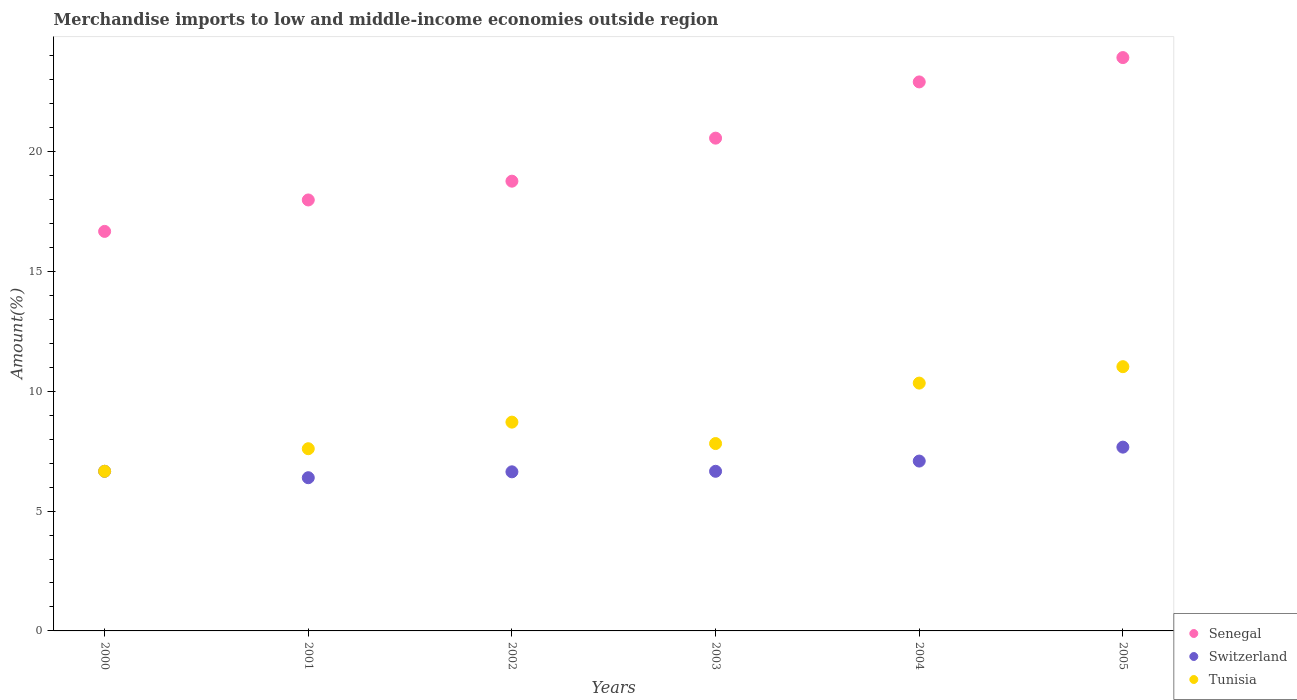Is the number of dotlines equal to the number of legend labels?
Keep it short and to the point. Yes. What is the percentage of amount earned from merchandise imports in Senegal in 2005?
Offer a terse response. 23.92. Across all years, what is the maximum percentage of amount earned from merchandise imports in Tunisia?
Offer a very short reply. 11.03. Across all years, what is the minimum percentage of amount earned from merchandise imports in Switzerland?
Offer a terse response. 6.39. What is the total percentage of amount earned from merchandise imports in Senegal in the graph?
Offer a terse response. 120.8. What is the difference between the percentage of amount earned from merchandise imports in Senegal in 2002 and that in 2005?
Your response must be concise. -5.16. What is the difference between the percentage of amount earned from merchandise imports in Senegal in 2001 and the percentage of amount earned from merchandise imports in Tunisia in 2005?
Provide a succinct answer. 6.96. What is the average percentage of amount earned from merchandise imports in Tunisia per year?
Make the answer very short. 8.69. In the year 2005, what is the difference between the percentage of amount earned from merchandise imports in Senegal and percentage of amount earned from merchandise imports in Switzerland?
Provide a short and direct response. 16.25. What is the ratio of the percentage of amount earned from merchandise imports in Senegal in 2003 to that in 2004?
Give a very brief answer. 0.9. Is the difference between the percentage of amount earned from merchandise imports in Senegal in 2001 and 2002 greater than the difference between the percentage of amount earned from merchandise imports in Switzerland in 2001 and 2002?
Give a very brief answer. No. What is the difference between the highest and the second highest percentage of amount earned from merchandise imports in Tunisia?
Offer a terse response. 0.69. What is the difference between the highest and the lowest percentage of amount earned from merchandise imports in Senegal?
Ensure brevity in your answer.  7.25. Is the percentage of amount earned from merchandise imports in Tunisia strictly greater than the percentage of amount earned from merchandise imports in Switzerland over the years?
Provide a succinct answer. Yes. How many dotlines are there?
Provide a short and direct response. 3. Does the graph contain grids?
Your response must be concise. No. Where does the legend appear in the graph?
Your response must be concise. Bottom right. How many legend labels are there?
Offer a very short reply. 3. What is the title of the graph?
Ensure brevity in your answer.  Merchandise imports to low and middle-income economies outside region. What is the label or title of the Y-axis?
Ensure brevity in your answer.  Amount(%). What is the Amount(%) in Senegal in 2000?
Provide a short and direct response. 16.67. What is the Amount(%) of Switzerland in 2000?
Make the answer very short. 6.66. What is the Amount(%) of Tunisia in 2000?
Your answer should be compact. 6.66. What is the Amount(%) in Senegal in 2001?
Provide a short and direct response. 17.98. What is the Amount(%) of Switzerland in 2001?
Your answer should be very brief. 6.39. What is the Amount(%) in Tunisia in 2001?
Make the answer very short. 7.6. What is the Amount(%) in Senegal in 2002?
Your response must be concise. 18.76. What is the Amount(%) in Switzerland in 2002?
Keep it short and to the point. 6.64. What is the Amount(%) in Tunisia in 2002?
Your response must be concise. 8.71. What is the Amount(%) in Senegal in 2003?
Provide a short and direct response. 20.56. What is the Amount(%) of Switzerland in 2003?
Make the answer very short. 6.66. What is the Amount(%) of Tunisia in 2003?
Make the answer very short. 7.82. What is the Amount(%) of Senegal in 2004?
Offer a very short reply. 22.91. What is the Amount(%) in Switzerland in 2004?
Provide a short and direct response. 7.09. What is the Amount(%) of Tunisia in 2004?
Make the answer very short. 10.34. What is the Amount(%) in Senegal in 2005?
Your answer should be very brief. 23.92. What is the Amount(%) of Switzerland in 2005?
Provide a short and direct response. 7.67. What is the Amount(%) in Tunisia in 2005?
Your answer should be compact. 11.03. Across all years, what is the maximum Amount(%) in Senegal?
Your answer should be compact. 23.92. Across all years, what is the maximum Amount(%) of Switzerland?
Keep it short and to the point. 7.67. Across all years, what is the maximum Amount(%) in Tunisia?
Your answer should be compact. 11.03. Across all years, what is the minimum Amount(%) in Senegal?
Make the answer very short. 16.67. Across all years, what is the minimum Amount(%) in Switzerland?
Keep it short and to the point. 6.39. Across all years, what is the minimum Amount(%) in Tunisia?
Your answer should be compact. 6.66. What is the total Amount(%) of Senegal in the graph?
Make the answer very short. 120.8. What is the total Amount(%) in Switzerland in the graph?
Make the answer very short. 41.11. What is the total Amount(%) of Tunisia in the graph?
Your answer should be very brief. 52.16. What is the difference between the Amount(%) in Senegal in 2000 and that in 2001?
Your answer should be compact. -1.31. What is the difference between the Amount(%) in Switzerland in 2000 and that in 2001?
Provide a short and direct response. 0.27. What is the difference between the Amount(%) of Tunisia in 2000 and that in 2001?
Ensure brevity in your answer.  -0.94. What is the difference between the Amount(%) of Senegal in 2000 and that in 2002?
Offer a terse response. -2.1. What is the difference between the Amount(%) in Switzerland in 2000 and that in 2002?
Keep it short and to the point. 0.02. What is the difference between the Amount(%) in Tunisia in 2000 and that in 2002?
Offer a very short reply. -2.05. What is the difference between the Amount(%) in Senegal in 2000 and that in 2003?
Provide a succinct answer. -3.89. What is the difference between the Amount(%) of Tunisia in 2000 and that in 2003?
Provide a short and direct response. -1.16. What is the difference between the Amount(%) in Senegal in 2000 and that in 2004?
Offer a very short reply. -6.24. What is the difference between the Amount(%) of Switzerland in 2000 and that in 2004?
Your answer should be very brief. -0.43. What is the difference between the Amount(%) in Tunisia in 2000 and that in 2004?
Offer a terse response. -3.68. What is the difference between the Amount(%) of Senegal in 2000 and that in 2005?
Your response must be concise. -7.25. What is the difference between the Amount(%) in Switzerland in 2000 and that in 2005?
Make the answer very short. -1.01. What is the difference between the Amount(%) in Tunisia in 2000 and that in 2005?
Give a very brief answer. -4.36. What is the difference between the Amount(%) of Senegal in 2001 and that in 2002?
Provide a short and direct response. -0.78. What is the difference between the Amount(%) of Switzerland in 2001 and that in 2002?
Provide a short and direct response. -0.25. What is the difference between the Amount(%) in Tunisia in 2001 and that in 2002?
Ensure brevity in your answer.  -1.11. What is the difference between the Amount(%) of Senegal in 2001 and that in 2003?
Offer a terse response. -2.58. What is the difference between the Amount(%) of Switzerland in 2001 and that in 2003?
Provide a short and direct response. -0.27. What is the difference between the Amount(%) in Tunisia in 2001 and that in 2003?
Keep it short and to the point. -0.22. What is the difference between the Amount(%) in Senegal in 2001 and that in 2004?
Give a very brief answer. -4.92. What is the difference between the Amount(%) of Switzerland in 2001 and that in 2004?
Your response must be concise. -0.69. What is the difference between the Amount(%) of Tunisia in 2001 and that in 2004?
Keep it short and to the point. -2.74. What is the difference between the Amount(%) in Senegal in 2001 and that in 2005?
Offer a very short reply. -5.94. What is the difference between the Amount(%) of Switzerland in 2001 and that in 2005?
Give a very brief answer. -1.28. What is the difference between the Amount(%) in Tunisia in 2001 and that in 2005?
Your answer should be compact. -3.42. What is the difference between the Amount(%) of Senegal in 2002 and that in 2003?
Provide a short and direct response. -1.8. What is the difference between the Amount(%) in Switzerland in 2002 and that in 2003?
Ensure brevity in your answer.  -0.02. What is the difference between the Amount(%) of Tunisia in 2002 and that in 2003?
Give a very brief answer. 0.89. What is the difference between the Amount(%) of Senegal in 2002 and that in 2004?
Your response must be concise. -4.14. What is the difference between the Amount(%) of Switzerland in 2002 and that in 2004?
Your response must be concise. -0.45. What is the difference between the Amount(%) in Tunisia in 2002 and that in 2004?
Offer a very short reply. -1.63. What is the difference between the Amount(%) in Senegal in 2002 and that in 2005?
Give a very brief answer. -5.16. What is the difference between the Amount(%) in Switzerland in 2002 and that in 2005?
Your answer should be very brief. -1.03. What is the difference between the Amount(%) of Tunisia in 2002 and that in 2005?
Make the answer very short. -2.31. What is the difference between the Amount(%) of Senegal in 2003 and that in 2004?
Your answer should be compact. -2.35. What is the difference between the Amount(%) in Switzerland in 2003 and that in 2004?
Keep it short and to the point. -0.43. What is the difference between the Amount(%) of Tunisia in 2003 and that in 2004?
Your answer should be compact. -2.52. What is the difference between the Amount(%) in Senegal in 2003 and that in 2005?
Your answer should be compact. -3.36. What is the difference between the Amount(%) in Switzerland in 2003 and that in 2005?
Make the answer very short. -1.01. What is the difference between the Amount(%) in Tunisia in 2003 and that in 2005?
Give a very brief answer. -3.21. What is the difference between the Amount(%) of Senegal in 2004 and that in 2005?
Keep it short and to the point. -1.02. What is the difference between the Amount(%) of Switzerland in 2004 and that in 2005?
Offer a terse response. -0.58. What is the difference between the Amount(%) in Tunisia in 2004 and that in 2005?
Provide a short and direct response. -0.69. What is the difference between the Amount(%) of Senegal in 2000 and the Amount(%) of Switzerland in 2001?
Ensure brevity in your answer.  10.28. What is the difference between the Amount(%) of Senegal in 2000 and the Amount(%) of Tunisia in 2001?
Provide a short and direct response. 9.07. What is the difference between the Amount(%) of Switzerland in 2000 and the Amount(%) of Tunisia in 2001?
Your answer should be compact. -0.94. What is the difference between the Amount(%) in Senegal in 2000 and the Amount(%) in Switzerland in 2002?
Give a very brief answer. 10.03. What is the difference between the Amount(%) of Senegal in 2000 and the Amount(%) of Tunisia in 2002?
Your answer should be compact. 7.96. What is the difference between the Amount(%) of Switzerland in 2000 and the Amount(%) of Tunisia in 2002?
Give a very brief answer. -2.05. What is the difference between the Amount(%) of Senegal in 2000 and the Amount(%) of Switzerland in 2003?
Your answer should be compact. 10.01. What is the difference between the Amount(%) of Senegal in 2000 and the Amount(%) of Tunisia in 2003?
Make the answer very short. 8.85. What is the difference between the Amount(%) in Switzerland in 2000 and the Amount(%) in Tunisia in 2003?
Give a very brief answer. -1.16. What is the difference between the Amount(%) in Senegal in 2000 and the Amount(%) in Switzerland in 2004?
Keep it short and to the point. 9.58. What is the difference between the Amount(%) in Senegal in 2000 and the Amount(%) in Tunisia in 2004?
Offer a terse response. 6.33. What is the difference between the Amount(%) in Switzerland in 2000 and the Amount(%) in Tunisia in 2004?
Your response must be concise. -3.68. What is the difference between the Amount(%) in Senegal in 2000 and the Amount(%) in Switzerland in 2005?
Offer a very short reply. 9. What is the difference between the Amount(%) of Senegal in 2000 and the Amount(%) of Tunisia in 2005?
Give a very brief answer. 5.64. What is the difference between the Amount(%) in Switzerland in 2000 and the Amount(%) in Tunisia in 2005?
Make the answer very short. -4.37. What is the difference between the Amount(%) in Senegal in 2001 and the Amount(%) in Switzerland in 2002?
Your answer should be very brief. 11.34. What is the difference between the Amount(%) of Senegal in 2001 and the Amount(%) of Tunisia in 2002?
Ensure brevity in your answer.  9.27. What is the difference between the Amount(%) in Switzerland in 2001 and the Amount(%) in Tunisia in 2002?
Your response must be concise. -2.32. What is the difference between the Amount(%) in Senegal in 2001 and the Amount(%) in Switzerland in 2003?
Offer a very short reply. 11.32. What is the difference between the Amount(%) in Senegal in 2001 and the Amount(%) in Tunisia in 2003?
Offer a very short reply. 10.16. What is the difference between the Amount(%) of Switzerland in 2001 and the Amount(%) of Tunisia in 2003?
Offer a terse response. -1.43. What is the difference between the Amount(%) in Senegal in 2001 and the Amount(%) in Switzerland in 2004?
Provide a succinct answer. 10.89. What is the difference between the Amount(%) of Senegal in 2001 and the Amount(%) of Tunisia in 2004?
Make the answer very short. 7.64. What is the difference between the Amount(%) of Switzerland in 2001 and the Amount(%) of Tunisia in 2004?
Your answer should be compact. -3.95. What is the difference between the Amount(%) in Senegal in 2001 and the Amount(%) in Switzerland in 2005?
Make the answer very short. 10.31. What is the difference between the Amount(%) of Senegal in 2001 and the Amount(%) of Tunisia in 2005?
Your response must be concise. 6.96. What is the difference between the Amount(%) in Switzerland in 2001 and the Amount(%) in Tunisia in 2005?
Provide a succinct answer. -4.63. What is the difference between the Amount(%) in Senegal in 2002 and the Amount(%) in Switzerland in 2003?
Your answer should be compact. 12.1. What is the difference between the Amount(%) in Senegal in 2002 and the Amount(%) in Tunisia in 2003?
Your response must be concise. 10.95. What is the difference between the Amount(%) of Switzerland in 2002 and the Amount(%) of Tunisia in 2003?
Provide a succinct answer. -1.18. What is the difference between the Amount(%) of Senegal in 2002 and the Amount(%) of Switzerland in 2004?
Provide a short and direct response. 11.68. What is the difference between the Amount(%) of Senegal in 2002 and the Amount(%) of Tunisia in 2004?
Keep it short and to the point. 8.42. What is the difference between the Amount(%) in Switzerland in 2002 and the Amount(%) in Tunisia in 2004?
Ensure brevity in your answer.  -3.7. What is the difference between the Amount(%) of Senegal in 2002 and the Amount(%) of Switzerland in 2005?
Keep it short and to the point. 11.1. What is the difference between the Amount(%) in Senegal in 2002 and the Amount(%) in Tunisia in 2005?
Provide a short and direct response. 7.74. What is the difference between the Amount(%) in Switzerland in 2002 and the Amount(%) in Tunisia in 2005?
Make the answer very short. -4.39. What is the difference between the Amount(%) in Senegal in 2003 and the Amount(%) in Switzerland in 2004?
Offer a very short reply. 13.47. What is the difference between the Amount(%) in Senegal in 2003 and the Amount(%) in Tunisia in 2004?
Provide a succinct answer. 10.22. What is the difference between the Amount(%) in Switzerland in 2003 and the Amount(%) in Tunisia in 2004?
Make the answer very short. -3.68. What is the difference between the Amount(%) of Senegal in 2003 and the Amount(%) of Switzerland in 2005?
Offer a very short reply. 12.89. What is the difference between the Amount(%) of Senegal in 2003 and the Amount(%) of Tunisia in 2005?
Offer a very short reply. 9.53. What is the difference between the Amount(%) of Switzerland in 2003 and the Amount(%) of Tunisia in 2005?
Make the answer very short. -4.37. What is the difference between the Amount(%) in Senegal in 2004 and the Amount(%) in Switzerland in 2005?
Ensure brevity in your answer.  15.24. What is the difference between the Amount(%) in Senegal in 2004 and the Amount(%) in Tunisia in 2005?
Keep it short and to the point. 11.88. What is the difference between the Amount(%) of Switzerland in 2004 and the Amount(%) of Tunisia in 2005?
Make the answer very short. -3.94. What is the average Amount(%) in Senegal per year?
Offer a very short reply. 20.13. What is the average Amount(%) of Switzerland per year?
Make the answer very short. 6.85. What is the average Amount(%) of Tunisia per year?
Keep it short and to the point. 8.69. In the year 2000, what is the difference between the Amount(%) of Senegal and Amount(%) of Switzerland?
Keep it short and to the point. 10.01. In the year 2000, what is the difference between the Amount(%) of Senegal and Amount(%) of Tunisia?
Provide a short and direct response. 10.01. In the year 2000, what is the difference between the Amount(%) in Switzerland and Amount(%) in Tunisia?
Your answer should be very brief. -0. In the year 2001, what is the difference between the Amount(%) in Senegal and Amount(%) in Switzerland?
Your answer should be compact. 11.59. In the year 2001, what is the difference between the Amount(%) of Senegal and Amount(%) of Tunisia?
Offer a terse response. 10.38. In the year 2001, what is the difference between the Amount(%) in Switzerland and Amount(%) in Tunisia?
Your answer should be compact. -1.21. In the year 2002, what is the difference between the Amount(%) in Senegal and Amount(%) in Switzerland?
Provide a succinct answer. 12.13. In the year 2002, what is the difference between the Amount(%) in Senegal and Amount(%) in Tunisia?
Provide a succinct answer. 10.05. In the year 2002, what is the difference between the Amount(%) of Switzerland and Amount(%) of Tunisia?
Provide a succinct answer. -2.07. In the year 2003, what is the difference between the Amount(%) of Senegal and Amount(%) of Switzerland?
Offer a very short reply. 13.9. In the year 2003, what is the difference between the Amount(%) in Senegal and Amount(%) in Tunisia?
Ensure brevity in your answer.  12.74. In the year 2003, what is the difference between the Amount(%) of Switzerland and Amount(%) of Tunisia?
Your response must be concise. -1.16. In the year 2004, what is the difference between the Amount(%) of Senegal and Amount(%) of Switzerland?
Offer a very short reply. 15.82. In the year 2004, what is the difference between the Amount(%) in Senegal and Amount(%) in Tunisia?
Offer a terse response. 12.57. In the year 2004, what is the difference between the Amount(%) in Switzerland and Amount(%) in Tunisia?
Provide a succinct answer. -3.25. In the year 2005, what is the difference between the Amount(%) of Senegal and Amount(%) of Switzerland?
Offer a very short reply. 16.25. In the year 2005, what is the difference between the Amount(%) of Senegal and Amount(%) of Tunisia?
Your answer should be compact. 12.9. In the year 2005, what is the difference between the Amount(%) of Switzerland and Amount(%) of Tunisia?
Offer a terse response. -3.36. What is the ratio of the Amount(%) in Senegal in 2000 to that in 2001?
Keep it short and to the point. 0.93. What is the ratio of the Amount(%) of Switzerland in 2000 to that in 2001?
Your response must be concise. 1.04. What is the ratio of the Amount(%) in Tunisia in 2000 to that in 2001?
Your response must be concise. 0.88. What is the ratio of the Amount(%) of Senegal in 2000 to that in 2002?
Provide a succinct answer. 0.89. What is the ratio of the Amount(%) in Tunisia in 2000 to that in 2002?
Give a very brief answer. 0.76. What is the ratio of the Amount(%) in Senegal in 2000 to that in 2003?
Provide a short and direct response. 0.81. What is the ratio of the Amount(%) in Switzerland in 2000 to that in 2003?
Your answer should be very brief. 1. What is the ratio of the Amount(%) in Tunisia in 2000 to that in 2003?
Offer a terse response. 0.85. What is the ratio of the Amount(%) in Senegal in 2000 to that in 2004?
Provide a succinct answer. 0.73. What is the ratio of the Amount(%) in Switzerland in 2000 to that in 2004?
Keep it short and to the point. 0.94. What is the ratio of the Amount(%) in Tunisia in 2000 to that in 2004?
Provide a succinct answer. 0.64. What is the ratio of the Amount(%) of Senegal in 2000 to that in 2005?
Your response must be concise. 0.7. What is the ratio of the Amount(%) in Switzerland in 2000 to that in 2005?
Offer a terse response. 0.87. What is the ratio of the Amount(%) in Tunisia in 2000 to that in 2005?
Your response must be concise. 0.6. What is the ratio of the Amount(%) in Senegal in 2001 to that in 2002?
Give a very brief answer. 0.96. What is the ratio of the Amount(%) in Tunisia in 2001 to that in 2002?
Keep it short and to the point. 0.87. What is the ratio of the Amount(%) of Senegal in 2001 to that in 2003?
Offer a terse response. 0.87. What is the ratio of the Amount(%) in Switzerland in 2001 to that in 2003?
Your answer should be compact. 0.96. What is the ratio of the Amount(%) of Tunisia in 2001 to that in 2003?
Provide a short and direct response. 0.97. What is the ratio of the Amount(%) in Senegal in 2001 to that in 2004?
Ensure brevity in your answer.  0.79. What is the ratio of the Amount(%) of Switzerland in 2001 to that in 2004?
Give a very brief answer. 0.9. What is the ratio of the Amount(%) of Tunisia in 2001 to that in 2004?
Make the answer very short. 0.74. What is the ratio of the Amount(%) of Senegal in 2001 to that in 2005?
Give a very brief answer. 0.75. What is the ratio of the Amount(%) in Switzerland in 2001 to that in 2005?
Ensure brevity in your answer.  0.83. What is the ratio of the Amount(%) in Tunisia in 2001 to that in 2005?
Give a very brief answer. 0.69. What is the ratio of the Amount(%) in Senegal in 2002 to that in 2003?
Your answer should be compact. 0.91. What is the ratio of the Amount(%) of Tunisia in 2002 to that in 2003?
Keep it short and to the point. 1.11. What is the ratio of the Amount(%) in Senegal in 2002 to that in 2004?
Keep it short and to the point. 0.82. What is the ratio of the Amount(%) of Switzerland in 2002 to that in 2004?
Your answer should be very brief. 0.94. What is the ratio of the Amount(%) in Tunisia in 2002 to that in 2004?
Offer a very short reply. 0.84. What is the ratio of the Amount(%) of Senegal in 2002 to that in 2005?
Your answer should be very brief. 0.78. What is the ratio of the Amount(%) of Switzerland in 2002 to that in 2005?
Provide a short and direct response. 0.87. What is the ratio of the Amount(%) of Tunisia in 2002 to that in 2005?
Ensure brevity in your answer.  0.79. What is the ratio of the Amount(%) in Senegal in 2003 to that in 2004?
Provide a succinct answer. 0.9. What is the ratio of the Amount(%) in Switzerland in 2003 to that in 2004?
Provide a succinct answer. 0.94. What is the ratio of the Amount(%) of Tunisia in 2003 to that in 2004?
Keep it short and to the point. 0.76. What is the ratio of the Amount(%) of Senegal in 2003 to that in 2005?
Your answer should be very brief. 0.86. What is the ratio of the Amount(%) of Switzerland in 2003 to that in 2005?
Keep it short and to the point. 0.87. What is the ratio of the Amount(%) of Tunisia in 2003 to that in 2005?
Provide a short and direct response. 0.71. What is the ratio of the Amount(%) in Senegal in 2004 to that in 2005?
Your answer should be compact. 0.96. What is the ratio of the Amount(%) of Switzerland in 2004 to that in 2005?
Keep it short and to the point. 0.92. What is the ratio of the Amount(%) of Tunisia in 2004 to that in 2005?
Your answer should be compact. 0.94. What is the difference between the highest and the second highest Amount(%) of Senegal?
Make the answer very short. 1.02. What is the difference between the highest and the second highest Amount(%) of Switzerland?
Provide a succinct answer. 0.58. What is the difference between the highest and the second highest Amount(%) in Tunisia?
Your answer should be very brief. 0.69. What is the difference between the highest and the lowest Amount(%) in Senegal?
Ensure brevity in your answer.  7.25. What is the difference between the highest and the lowest Amount(%) in Switzerland?
Offer a very short reply. 1.28. What is the difference between the highest and the lowest Amount(%) of Tunisia?
Your response must be concise. 4.36. 